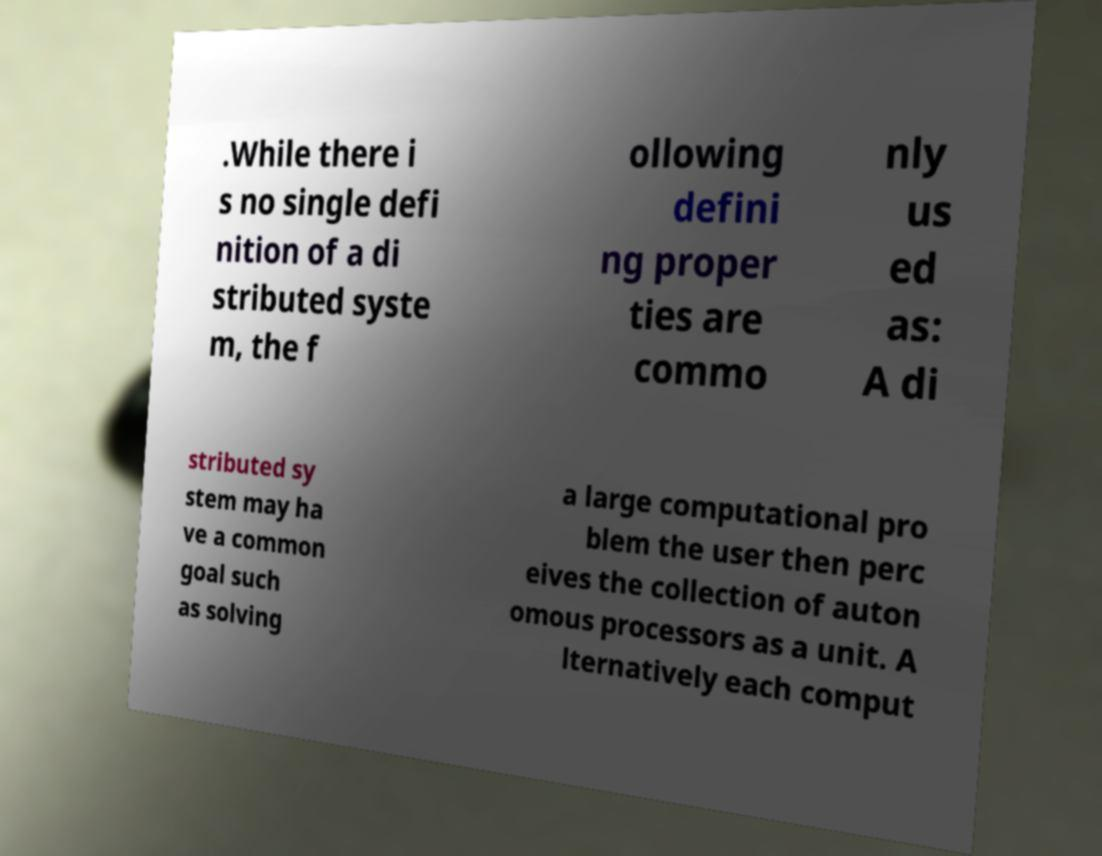Can you read and provide the text displayed in the image?This photo seems to have some interesting text. Can you extract and type it out for me? .While there i s no single defi nition of a di stributed syste m, the f ollowing defini ng proper ties are commo nly us ed as: A di stributed sy stem may ha ve a common goal such as solving a large computational pro blem the user then perc eives the collection of auton omous processors as a unit. A lternatively each comput 